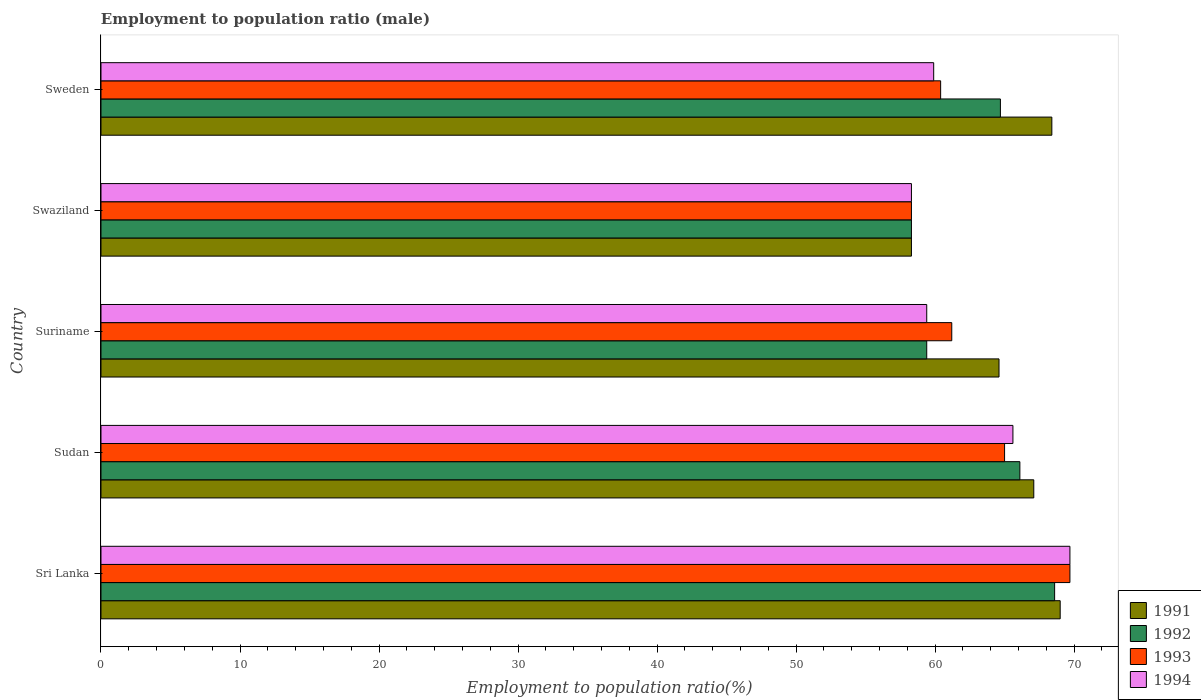How many different coloured bars are there?
Give a very brief answer. 4. How many groups of bars are there?
Ensure brevity in your answer.  5. Are the number of bars per tick equal to the number of legend labels?
Ensure brevity in your answer.  Yes. How many bars are there on the 4th tick from the bottom?
Your answer should be compact. 4. What is the label of the 4th group of bars from the top?
Make the answer very short. Sudan. Across all countries, what is the maximum employment to population ratio in 1994?
Keep it short and to the point. 69.7. Across all countries, what is the minimum employment to population ratio in 1992?
Offer a very short reply. 58.3. In which country was the employment to population ratio in 1993 maximum?
Your response must be concise. Sri Lanka. In which country was the employment to population ratio in 1993 minimum?
Keep it short and to the point. Swaziland. What is the total employment to population ratio in 1993 in the graph?
Provide a succinct answer. 314.6. What is the difference between the employment to population ratio in 1994 in Sudan and that in Sweden?
Provide a short and direct response. 5.7. What is the difference between the employment to population ratio in 1992 in Swaziland and the employment to population ratio in 1994 in Sri Lanka?
Provide a short and direct response. -11.4. What is the average employment to population ratio in 1993 per country?
Provide a short and direct response. 62.92. What is the difference between the employment to population ratio in 1992 and employment to population ratio in 1994 in Sudan?
Give a very brief answer. 0.5. In how many countries, is the employment to population ratio in 1991 greater than 4 %?
Provide a short and direct response. 5. What is the ratio of the employment to population ratio in 1993 in Suriname to that in Sweden?
Your answer should be very brief. 1.01. Is the employment to population ratio in 1993 in Sudan less than that in Sweden?
Provide a short and direct response. No. What is the difference between the highest and the second highest employment to population ratio in 1993?
Your response must be concise. 4.7. What is the difference between the highest and the lowest employment to population ratio in 1993?
Offer a terse response. 11.4. Is it the case that in every country, the sum of the employment to population ratio in 1992 and employment to population ratio in 1994 is greater than the sum of employment to population ratio in 1993 and employment to population ratio in 1991?
Provide a succinct answer. No. What does the 2nd bar from the top in Sudan represents?
Your answer should be very brief. 1993. What does the 3rd bar from the bottom in Suriname represents?
Offer a terse response. 1993. What is the difference between two consecutive major ticks on the X-axis?
Your response must be concise. 10. How are the legend labels stacked?
Provide a short and direct response. Vertical. What is the title of the graph?
Your answer should be compact. Employment to population ratio (male). What is the label or title of the Y-axis?
Provide a short and direct response. Country. What is the Employment to population ratio(%) in 1991 in Sri Lanka?
Give a very brief answer. 69. What is the Employment to population ratio(%) in 1992 in Sri Lanka?
Your answer should be very brief. 68.6. What is the Employment to population ratio(%) in 1993 in Sri Lanka?
Offer a terse response. 69.7. What is the Employment to population ratio(%) in 1994 in Sri Lanka?
Ensure brevity in your answer.  69.7. What is the Employment to population ratio(%) in 1991 in Sudan?
Offer a terse response. 67.1. What is the Employment to population ratio(%) of 1992 in Sudan?
Ensure brevity in your answer.  66.1. What is the Employment to population ratio(%) in 1994 in Sudan?
Give a very brief answer. 65.6. What is the Employment to population ratio(%) in 1991 in Suriname?
Offer a terse response. 64.6. What is the Employment to population ratio(%) in 1992 in Suriname?
Ensure brevity in your answer.  59.4. What is the Employment to population ratio(%) in 1993 in Suriname?
Ensure brevity in your answer.  61.2. What is the Employment to population ratio(%) of 1994 in Suriname?
Make the answer very short. 59.4. What is the Employment to population ratio(%) of 1991 in Swaziland?
Offer a very short reply. 58.3. What is the Employment to population ratio(%) of 1992 in Swaziland?
Offer a terse response. 58.3. What is the Employment to population ratio(%) of 1993 in Swaziland?
Provide a short and direct response. 58.3. What is the Employment to population ratio(%) in 1994 in Swaziland?
Make the answer very short. 58.3. What is the Employment to population ratio(%) of 1991 in Sweden?
Offer a very short reply. 68.4. What is the Employment to population ratio(%) in 1992 in Sweden?
Your response must be concise. 64.7. What is the Employment to population ratio(%) of 1993 in Sweden?
Provide a short and direct response. 60.4. What is the Employment to population ratio(%) of 1994 in Sweden?
Your response must be concise. 59.9. Across all countries, what is the maximum Employment to population ratio(%) in 1992?
Keep it short and to the point. 68.6. Across all countries, what is the maximum Employment to population ratio(%) in 1993?
Offer a very short reply. 69.7. Across all countries, what is the maximum Employment to population ratio(%) in 1994?
Provide a succinct answer. 69.7. Across all countries, what is the minimum Employment to population ratio(%) of 1991?
Ensure brevity in your answer.  58.3. Across all countries, what is the minimum Employment to population ratio(%) of 1992?
Keep it short and to the point. 58.3. Across all countries, what is the minimum Employment to population ratio(%) in 1993?
Provide a succinct answer. 58.3. Across all countries, what is the minimum Employment to population ratio(%) in 1994?
Give a very brief answer. 58.3. What is the total Employment to population ratio(%) of 1991 in the graph?
Ensure brevity in your answer.  327.4. What is the total Employment to population ratio(%) of 1992 in the graph?
Your response must be concise. 317.1. What is the total Employment to population ratio(%) in 1993 in the graph?
Make the answer very short. 314.6. What is the total Employment to population ratio(%) of 1994 in the graph?
Provide a succinct answer. 312.9. What is the difference between the Employment to population ratio(%) of 1991 in Sri Lanka and that in Sudan?
Make the answer very short. 1.9. What is the difference between the Employment to population ratio(%) in 1993 in Sri Lanka and that in Sudan?
Your answer should be compact. 4.7. What is the difference between the Employment to population ratio(%) of 1994 in Sri Lanka and that in Sudan?
Provide a succinct answer. 4.1. What is the difference between the Employment to population ratio(%) of 1991 in Sri Lanka and that in Suriname?
Provide a short and direct response. 4.4. What is the difference between the Employment to population ratio(%) in 1994 in Sri Lanka and that in Suriname?
Your answer should be compact. 10.3. What is the difference between the Employment to population ratio(%) of 1991 in Sri Lanka and that in Sweden?
Your answer should be very brief. 0.6. What is the difference between the Employment to population ratio(%) in 1993 in Sri Lanka and that in Sweden?
Make the answer very short. 9.3. What is the difference between the Employment to population ratio(%) in 1992 in Sudan and that in Suriname?
Provide a succinct answer. 6.7. What is the difference between the Employment to population ratio(%) of 1994 in Sudan and that in Swaziland?
Ensure brevity in your answer.  7.3. What is the difference between the Employment to population ratio(%) in 1991 in Sudan and that in Sweden?
Your response must be concise. -1.3. What is the difference between the Employment to population ratio(%) of 1992 in Sudan and that in Sweden?
Offer a terse response. 1.4. What is the difference between the Employment to population ratio(%) of 1994 in Sudan and that in Sweden?
Give a very brief answer. 5.7. What is the difference between the Employment to population ratio(%) in 1991 in Suriname and that in Swaziland?
Offer a very short reply. 6.3. What is the difference between the Employment to population ratio(%) in 1993 in Suriname and that in Swaziland?
Provide a succinct answer. 2.9. What is the difference between the Employment to population ratio(%) of 1994 in Suriname and that in Swaziland?
Ensure brevity in your answer.  1.1. What is the difference between the Employment to population ratio(%) of 1991 in Suriname and that in Sweden?
Keep it short and to the point. -3.8. What is the difference between the Employment to population ratio(%) of 1992 in Suriname and that in Sweden?
Provide a short and direct response. -5.3. What is the difference between the Employment to population ratio(%) of 1993 in Suriname and that in Sweden?
Provide a succinct answer. 0.8. What is the difference between the Employment to population ratio(%) in 1993 in Swaziland and that in Sweden?
Offer a terse response. -2.1. What is the difference between the Employment to population ratio(%) in 1994 in Swaziland and that in Sweden?
Keep it short and to the point. -1.6. What is the difference between the Employment to population ratio(%) in 1991 in Sri Lanka and the Employment to population ratio(%) in 1994 in Sudan?
Your response must be concise. 3.4. What is the difference between the Employment to population ratio(%) in 1992 in Sri Lanka and the Employment to population ratio(%) in 1993 in Sudan?
Offer a very short reply. 3.6. What is the difference between the Employment to population ratio(%) of 1992 in Sri Lanka and the Employment to population ratio(%) of 1994 in Sudan?
Make the answer very short. 3. What is the difference between the Employment to population ratio(%) of 1993 in Sri Lanka and the Employment to population ratio(%) of 1994 in Sudan?
Ensure brevity in your answer.  4.1. What is the difference between the Employment to population ratio(%) in 1991 in Sri Lanka and the Employment to population ratio(%) in 1993 in Suriname?
Your answer should be compact. 7.8. What is the difference between the Employment to population ratio(%) in 1992 in Sri Lanka and the Employment to population ratio(%) in 1993 in Suriname?
Provide a succinct answer. 7.4. What is the difference between the Employment to population ratio(%) in 1992 in Sri Lanka and the Employment to population ratio(%) in 1994 in Suriname?
Provide a short and direct response. 9.2. What is the difference between the Employment to population ratio(%) in 1993 in Sri Lanka and the Employment to population ratio(%) in 1994 in Suriname?
Make the answer very short. 10.3. What is the difference between the Employment to population ratio(%) of 1991 in Sri Lanka and the Employment to population ratio(%) of 1993 in Swaziland?
Give a very brief answer. 10.7. What is the difference between the Employment to population ratio(%) in 1991 in Sri Lanka and the Employment to population ratio(%) in 1994 in Swaziland?
Keep it short and to the point. 10.7. What is the difference between the Employment to population ratio(%) of 1992 in Sri Lanka and the Employment to population ratio(%) of 1993 in Swaziland?
Offer a terse response. 10.3. What is the difference between the Employment to population ratio(%) in 1992 in Sri Lanka and the Employment to population ratio(%) in 1994 in Swaziland?
Your response must be concise. 10.3. What is the difference between the Employment to population ratio(%) in 1993 in Sri Lanka and the Employment to population ratio(%) in 1994 in Swaziland?
Offer a terse response. 11.4. What is the difference between the Employment to population ratio(%) of 1991 in Sri Lanka and the Employment to population ratio(%) of 1993 in Sweden?
Offer a terse response. 8.6. What is the difference between the Employment to population ratio(%) in 1992 in Sri Lanka and the Employment to population ratio(%) in 1994 in Sweden?
Give a very brief answer. 8.7. What is the difference between the Employment to population ratio(%) of 1991 in Sudan and the Employment to population ratio(%) of 1992 in Suriname?
Offer a terse response. 7.7. What is the difference between the Employment to population ratio(%) of 1992 in Sudan and the Employment to population ratio(%) of 1993 in Suriname?
Your response must be concise. 4.9. What is the difference between the Employment to population ratio(%) of 1992 in Sudan and the Employment to population ratio(%) of 1994 in Suriname?
Offer a terse response. 6.7. What is the difference between the Employment to population ratio(%) of 1991 in Sudan and the Employment to population ratio(%) of 1992 in Swaziland?
Give a very brief answer. 8.8. What is the difference between the Employment to population ratio(%) in 1991 in Sudan and the Employment to population ratio(%) in 1993 in Swaziland?
Your answer should be very brief. 8.8. What is the difference between the Employment to population ratio(%) in 1991 in Sudan and the Employment to population ratio(%) in 1994 in Swaziland?
Your answer should be compact. 8.8. What is the difference between the Employment to population ratio(%) in 1993 in Sudan and the Employment to population ratio(%) in 1994 in Swaziland?
Your answer should be compact. 6.7. What is the difference between the Employment to population ratio(%) in 1991 in Sudan and the Employment to population ratio(%) in 1993 in Sweden?
Offer a terse response. 6.7. What is the difference between the Employment to population ratio(%) of 1991 in Sudan and the Employment to population ratio(%) of 1994 in Sweden?
Your answer should be very brief. 7.2. What is the difference between the Employment to population ratio(%) in 1991 in Suriname and the Employment to population ratio(%) in 1993 in Swaziland?
Offer a terse response. 6.3. What is the difference between the Employment to population ratio(%) in 1991 in Suriname and the Employment to population ratio(%) in 1994 in Swaziland?
Your answer should be very brief. 6.3. What is the difference between the Employment to population ratio(%) in 1992 in Suriname and the Employment to population ratio(%) in 1994 in Swaziland?
Provide a succinct answer. 1.1. What is the difference between the Employment to population ratio(%) of 1991 in Swaziland and the Employment to population ratio(%) of 1993 in Sweden?
Give a very brief answer. -2.1. What is the difference between the Employment to population ratio(%) of 1992 in Swaziland and the Employment to population ratio(%) of 1994 in Sweden?
Make the answer very short. -1.6. What is the difference between the Employment to population ratio(%) of 1993 in Swaziland and the Employment to population ratio(%) of 1994 in Sweden?
Offer a terse response. -1.6. What is the average Employment to population ratio(%) of 1991 per country?
Ensure brevity in your answer.  65.48. What is the average Employment to population ratio(%) in 1992 per country?
Provide a short and direct response. 63.42. What is the average Employment to population ratio(%) of 1993 per country?
Keep it short and to the point. 62.92. What is the average Employment to population ratio(%) in 1994 per country?
Provide a short and direct response. 62.58. What is the difference between the Employment to population ratio(%) in 1991 and Employment to population ratio(%) in 1992 in Sri Lanka?
Make the answer very short. 0.4. What is the difference between the Employment to population ratio(%) of 1991 and Employment to population ratio(%) of 1993 in Sri Lanka?
Ensure brevity in your answer.  -0.7. What is the difference between the Employment to population ratio(%) of 1992 and Employment to population ratio(%) of 1994 in Sri Lanka?
Provide a short and direct response. -1.1. What is the difference between the Employment to population ratio(%) of 1991 and Employment to population ratio(%) of 1993 in Sudan?
Your answer should be compact. 2.1. What is the difference between the Employment to population ratio(%) in 1991 and Employment to population ratio(%) in 1994 in Sudan?
Provide a short and direct response. 1.5. What is the difference between the Employment to population ratio(%) in 1992 and Employment to population ratio(%) in 1994 in Sudan?
Your response must be concise. 0.5. What is the difference between the Employment to population ratio(%) in 1991 and Employment to population ratio(%) in 1992 in Suriname?
Your response must be concise. 5.2. What is the difference between the Employment to population ratio(%) of 1991 and Employment to population ratio(%) of 1994 in Suriname?
Your response must be concise. 5.2. What is the difference between the Employment to population ratio(%) of 1992 and Employment to population ratio(%) of 1994 in Suriname?
Provide a succinct answer. 0. What is the difference between the Employment to population ratio(%) in 1993 and Employment to population ratio(%) in 1994 in Suriname?
Make the answer very short. 1.8. What is the difference between the Employment to population ratio(%) in 1991 and Employment to population ratio(%) in 1994 in Swaziland?
Your answer should be very brief. 0. What is the difference between the Employment to population ratio(%) in 1992 and Employment to population ratio(%) in 1993 in Swaziland?
Offer a very short reply. 0. What is the difference between the Employment to population ratio(%) in 1992 and Employment to population ratio(%) in 1994 in Swaziland?
Offer a terse response. 0. What is the difference between the Employment to population ratio(%) of 1993 and Employment to population ratio(%) of 1994 in Swaziland?
Offer a very short reply. 0. What is the difference between the Employment to population ratio(%) of 1991 and Employment to population ratio(%) of 1992 in Sweden?
Make the answer very short. 3.7. What is the difference between the Employment to population ratio(%) of 1991 and Employment to population ratio(%) of 1993 in Sweden?
Provide a short and direct response. 8. What is the difference between the Employment to population ratio(%) in 1991 and Employment to population ratio(%) in 1994 in Sweden?
Make the answer very short. 8.5. What is the difference between the Employment to population ratio(%) in 1992 and Employment to population ratio(%) in 1993 in Sweden?
Offer a terse response. 4.3. What is the difference between the Employment to population ratio(%) in 1992 and Employment to population ratio(%) in 1994 in Sweden?
Make the answer very short. 4.8. What is the ratio of the Employment to population ratio(%) of 1991 in Sri Lanka to that in Sudan?
Give a very brief answer. 1.03. What is the ratio of the Employment to population ratio(%) of 1992 in Sri Lanka to that in Sudan?
Offer a very short reply. 1.04. What is the ratio of the Employment to population ratio(%) of 1993 in Sri Lanka to that in Sudan?
Your response must be concise. 1.07. What is the ratio of the Employment to population ratio(%) in 1994 in Sri Lanka to that in Sudan?
Give a very brief answer. 1.06. What is the ratio of the Employment to population ratio(%) of 1991 in Sri Lanka to that in Suriname?
Provide a short and direct response. 1.07. What is the ratio of the Employment to population ratio(%) of 1992 in Sri Lanka to that in Suriname?
Keep it short and to the point. 1.15. What is the ratio of the Employment to population ratio(%) of 1993 in Sri Lanka to that in Suriname?
Keep it short and to the point. 1.14. What is the ratio of the Employment to population ratio(%) in 1994 in Sri Lanka to that in Suriname?
Ensure brevity in your answer.  1.17. What is the ratio of the Employment to population ratio(%) of 1991 in Sri Lanka to that in Swaziland?
Make the answer very short. 1.18. What is the ratio of the Employment to population ratio(%) of 1992 in Sri Lanka to that in Swaziland?
Offer a very short reply. 1.18. What is the ratio of the Employment to population ratio(%) in 1993 in Sri Lanka to that in Swaziland?
Provide a succinct answer. 1.2. What is the ratio of the Employment to population ratio(%) in 1994 in Sri Lanka to that in Swaziland?
Provide a succinct answer. 1.2. What is the ratio of the Employment to population ratio(%) in 1991 in Sri Lanka to that in Sweden?
Ensure brevity in your answer.  1.01. What is the ratio of the Employment to population ratio(%) of 1992 in Sri Lanka to that in Sweden?
Keep it short and to the point. 1.06. What is the ratio of the Employment to population ratio(%) of 1993 in Sri Lanka to that in Sweden?
Make the answer very short. 1.15. What is the ratio of the Employment to population ratio(%) in 1994 in Sri Lanka to that in Sweden?
Offer a terse response. 1.16. What is the ratio of the Employment to population ratio(%) in 1991 in Sudan to that in Suriname?
Provide a short and direct response. 1.04. What is the ratio of the Employment to population ratio(%) in 1992 in Sudan to that in Suriname?
Ensure brevity in your answer.  1.11. What is the ratio of the Employment to population ratio(%) in 1993 in Sudan to that in Suriname?
Your response must be concise. 1.06. What is the ratio of the Employment to population ratio(%) in 1994 in Sudan to that in Suriname?
Your response must be concise. 1.1. What is the ratio of the Employment to population ratio(%) of 1991 in Sudan to that in Swaziland?
Offer a very short reply. 1.15. What is the ratio of the Employment to population ratio(%) of 1992 in Sudan to that in Swaziland?
Offer a very short reply. 1.13. What is the ratio of the Employment to population ratio(%) in 1993 in Sudan to that in Swaziland?
Make the answer very short. 1.11. What is the ratio of the Employment to population ratio(%) in 1994 in Sudan to that in Swaziland?
Make the answer very short. 1.13. What is the ratio of the Employment to population ratio(%) in 1991 in Sudan to that in Sweden?
Your response must be concise. 0.98. What is the ratio of the Employment to population ratio(%) in 1992 in Sudan to that in Sweden?
Your answer should be compact. 1.02. What is the ratio of the Employment to population ratio(%) of 1993 in Sudan to that in Sweden?
Provide a succinct answer. 1.08. What is the ratio of the Employment to population ratio(%) of 1994 in Sudan to that in Sweden?
Your answer should be very brief. 1.1. What is the ratio of the Employment to population ratio(%) of 1991 in Suriname to that in Swaziland?
Offer a terse response. 1.11. What is the ratio of the Employment to population ratio(%) of 1992 in Suriname to that in Swaziland?
Provide a short and direct response. 1.02. What is the ratio of the Employment to population ratio(%) in 1993 in Suriname to that in Swaziland?
Give a very brief answer. 1.05. What is the ratio of the Employment to population ratio(%) in 1994 in Suriname to that in Swaziland?
Your answer should be compact. 1.02. What is the ratio of the Employment to population ratio(%) in 1992 in Suriname to that in Sweden?
Ensure brevity in your answer.  0.92. What is the ratio of the Employment to population ratio(%) of 1993 in Suriname to that in Sweden?
Give a very brief answer. 1.01. What is the ratio of the Employment to population ratio(%) of 1991 in Swaziland to that in Sweden?
Your answer should be very brief. 0.85. What is the ratio of the Employment to population ratio(%) of 1992 in Swaziland to that in Sweden?
Your answer should be compact. 0.9. What is the ratio of the Employment to population ratio(%) in 1993 in Swaziland to that in Sweden?
Your answer should be compact. 0.97. What is the ratio of the Employment to population ratio(%) in 1994 in Swaziland to that in Sweden?
Your response must be concise. 0.97. What is the difference between the highest and the second highest Employment to population ratio(%) in 1992?
Offer a very short reply. 2.5. What is the difference between the highest and the second highest Employment to population ratio(%) in 1993?
Provide a short and direct response. 4.7. What is the difference between the highest and the lowest Employment to population ratio(%) of 1993?
Provide a short and direct response. 11.4. 